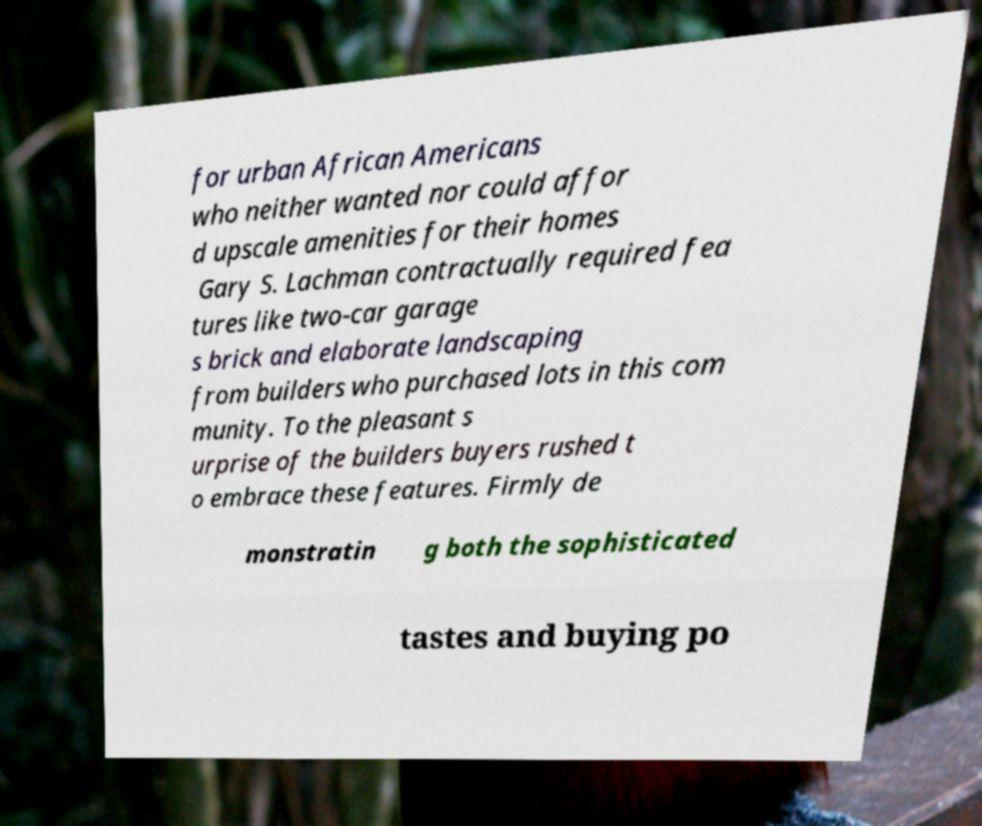I need the written content from this picture converted into text. Can you do that? for urban African Americans who neither wanted nor could affor d upscale amenities for their homes Gary S. Lachman contractually required fea tures like two-car garage s brick and elaborate landscaping from builders who purchased lots in this com munity. To the pleasant s urprise of the builders buyers rushed t o embrace these features. Firmly de monstratin g both the sophisticated tastes and buying po 